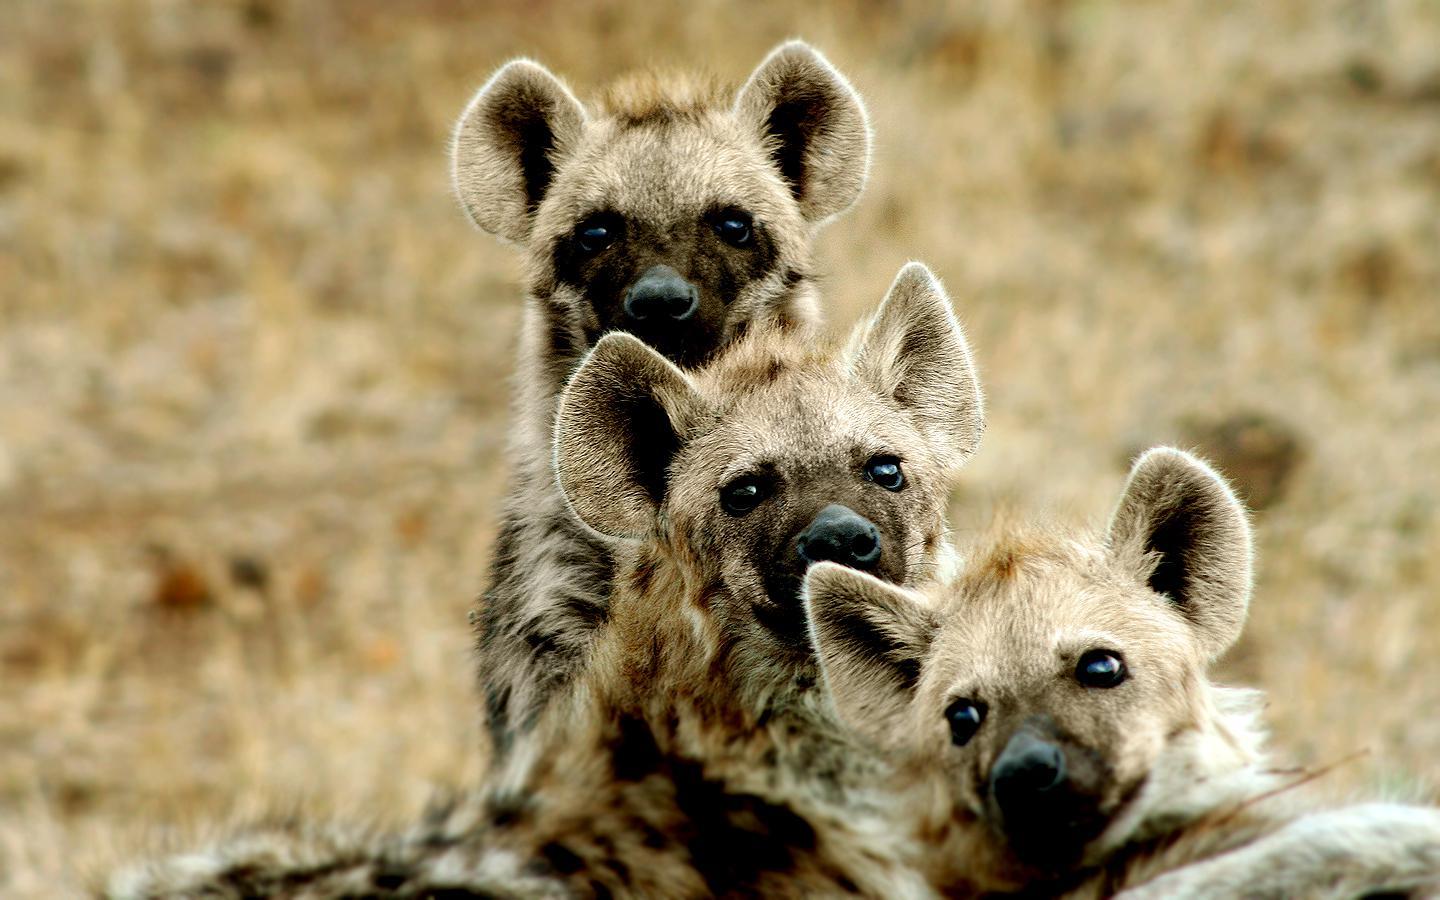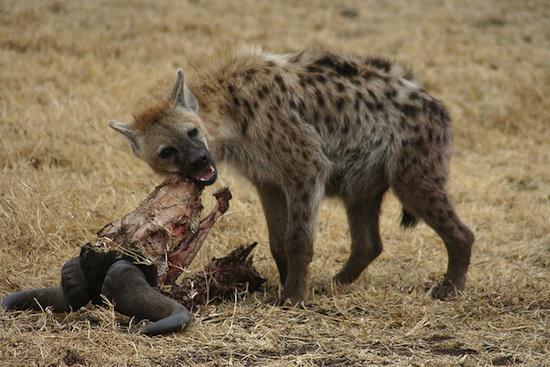The first image is the image on the left, the second image is the image on the right. Assess this claim about the two images: "An image shows a closely grouped trio of hyenas looking at the camera, all with closed mouths.". Correct or not? Answer yes or no. Yes. 